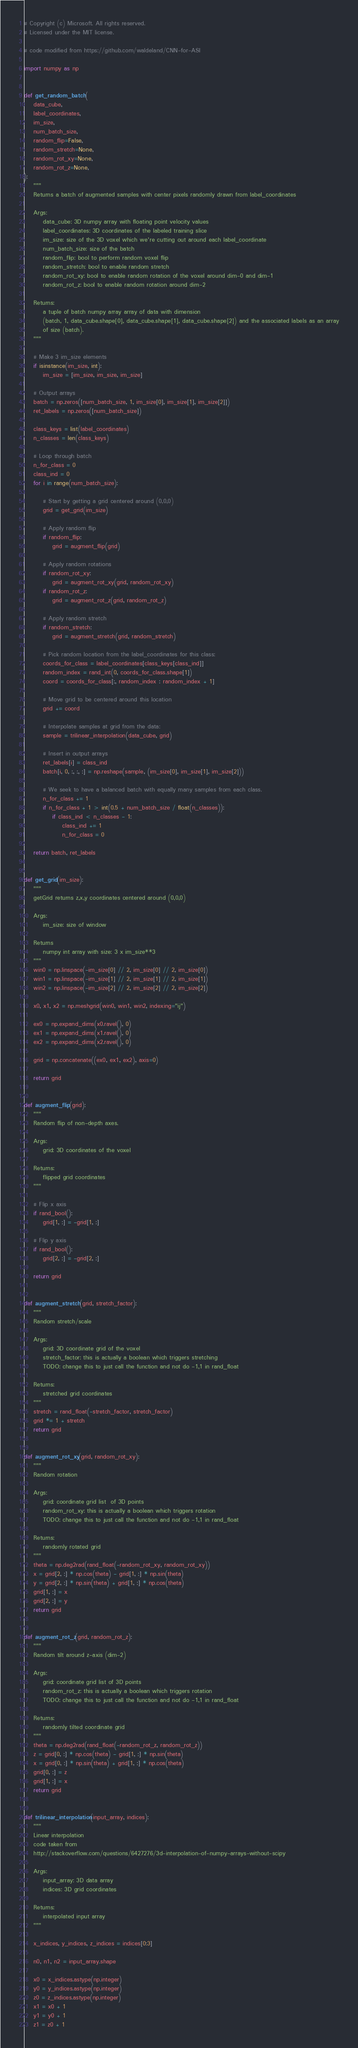Convert code to text. <code><loc_0><loc_0><loc_500><loc_500><_Python_># Copyright (c) Microsoft. All rights reserved.
# Licensed under the MIT license.

# code modified from https://github.com/waldeland/CNN-for-ASI

import numpy as np


def get_random_batch(
    data_cube,
    label_coordinates,
    im_size,
    num_batch_size,
    random_flip=False,
    random_stretch=None,
    random_rot_xy=None,
    random_rot_z=None,
):
    """
    Returns a batch of augmented samples with center pixels randomly drawn from label_coordinates

    Args:
        data_cube: 3D numpy array with floating point velocity values
        label_coordinates: 3D coordinates of the labeled training slice
        im_size: size of the 3D voxel which we're cutting out around each label_coordinate
        num_batch_size: size of the batch
        random_flip: bool to perform random voxel flip
        random_stretch: bool to enable random stretch
        random_rot_xy: bool to enable random rotation of the voxel around dim-0 and dim-1
        random_rot_z: bool to enable random rotation around dim-2

    Returns:
        a tuple of batch numpy array array of data with dimension
        (batch, 1, data_cube.shape[0], data_cube.shape[1], data_cube.shape[2]) and the associated labels as an array
        of size (batch).
    """

    # Make 3 im_size elements
    if isinstance(im_size, int):
        im_size = [im_size, im_size, im_size]

    # Output arrays
    batch = np.zeros([num_batch_size, 1, im_size[0], im_size[1], im_size[2]])
    ret_labels = np.zeros([num_batch_size])

    class_keys = list(label_coordinates)
    n_classes = len(class_keys)

    # Loop through batch
    n_for_class = 0
    class_ind = 0
    for i in range(num_batch_size):

        # Start by getting a grid centered around (0,0,0)
        grid = get_grid(im_size)

        # Apply random flip
        if random_flip:
            grid = augment_flip(grid)

        # Apply random rotations
        if random_rot_xy:
            grid = augment_rot_xy(grid, random_rot_xy)
        if random_rot_z:
            grid = augment_rot_z(grid, random_rot_z)

        # Apply random stretch
        if random_stretch:
            grid = augment_stretch(grid, random_stretch)

        # Pick random location from the label_coordinates for this class:
        coords_for_class = label_coordinates[class_keys[class_ind]]
        random_index = rand_int(0, coords_for_class.shape[1])
        coord = coords_for_class[:, random_index : random_index + 1]

        # Move grid to be centered around this location
        grid += coord

        # Interpolate samples at grid from the data:
        sample = trilinear_interpolation(data_cube, grid)

        # Insert in output arrays
        ret_labels[i] = class_ind
        batch[i, 0, :, :, :] = np.reshape(sample, (im_size[0], im_size[1], im_size[2]))

        # We seek to have a balanced batch with equally many samples from each class.
        n_for_class += 1
        if n_for_class + 1 > int(0.5 + num_batch_size / float(n_classes)):
            if class_ind < n_classes - 1:
                class_ind += 1
                n_for_class = 0

    return batch, ret_labels


def get_grid(im_size):
    """
    getGrid returns z,x,y coordinates centered around (0,0,0)

    Args:
        im_size: size of window

    Returns
        numpy int array with size: 3 x im_size**3
    """
    win0 = np.linspace(-im_size[0] // 2, im_size[0] // 2, im_size[0])
    win1 = np.linspace(-im_size[1] // 2, im_size[1] // 2, im_size[1])
    win2 = np.linspace(-im_size[2] // 2, im_size[2] // 2, im_size[2])

    x0, x1, x2 = np.meshgrid(win0, win1, win2, indexing="ij")

    ex0 = np.expand_dims(x0.ravel(), 0)
    ex1 = np.expand_dims(x1.ravel(), 0)
    ex2 = np.expand_dims(x2.ravel(), 0)

    grid = np.concatenate((ex0, ex1, ex2), axis=0)

    return grid


def augment_flip(grid):
    """
    Random flip of non-depth axes.

    Args:
        grid: 3D coordinates of the voxel

    Returns:
        flipped grid coordinates
    """

    # Flip x axis
    if rand_bool():
        grid[1, :] = -grid[1, :]

    # Flip y axis
    if rand_bool():
        grid[2, :] = -grid[2, :]

    return grid


def augment_stretch(grid, stretch_factor):
    """
    Random stretch/scale

    Args:
        grid: 3D coordinate grid of the voxel
        stretch_factor: this is actually a boolean which triggers stretching
        TODO: change this to just call the function and not do -1,1 in rand_float

    Returns:
        stretched grid coordinates
    """
    stretch = rand_float(-stretch_factor, stretch_factor)
    grid *= 1 + stretch
    return grid


def augment_rot_xy(grid, random_rot_xy):
    """
    Random rotation

    Args:
        grid: coordinate grid list  of 3D points
        random_rot_xy: this is actually a boolean which triggers rotation
        TODO: change this to just call the function and not do -1,1 in rand_float

    Returns:
        randomly rotated grid
    """
    theta = np.deg2rad(rand_float(-random_rot_xy, random_rot_xy))
    x = grid[2, :] * np.cos(theta) - grid[1, :] * np.sin(theta)
    y = grid[2, :] * np.sin(theta) + grid[1, :] * np.cos(theta)
    grid[1, :] = x
    grid[2, :] = y
    return grid


def augment_rot_z(grid, random_rot_z):
    """
    Random tilt around z-axis (dim-2)

    Args:
        grid: coordinate grid list of 3D points
        random_rot_z: this is actually a boolean which triggers rotation
        TODO: change this to just call the function and not do -1,1 in rand_float

    Returns:
        randomly tilted coordinate grid
    """
    theta = np.deg2rad(rand_float(-random_rot_z, random_rot_z))
    z = grid[0, :] * np.cos(theta) - grid[1, :] * np.sin(theta)
    x = grid[0, :] * np.sin(theta) + grid[1, :] * np.cos(theta)
    grid[0, :] = z
    grid[1, :] = x
    return grid


def trilinear_interpolation(input_array, indices):
    """
    Linear interpolation
    code taken from
    http://stackoverflow.com/questions/6427276/3d-interpolation-of-numpy-arrays-without-scipy

    Args:
        input_array: 3D data array
        indices: 3D grid coordinates

    Returns:
        interpolated input array
    """

    x_indices, y_indices, z_indices = indices[0:3]

    n0, n1, n2 = input_array.shape

    x0 = x_indices.astype(np.integer)
    y0 = y_indices.astype(np.integer)
    z0 = z_indices.astype(np.integer)
    x1 = x0 + 1
    y1 = y0 + 1
    z1 = z0 + 1
</code> 